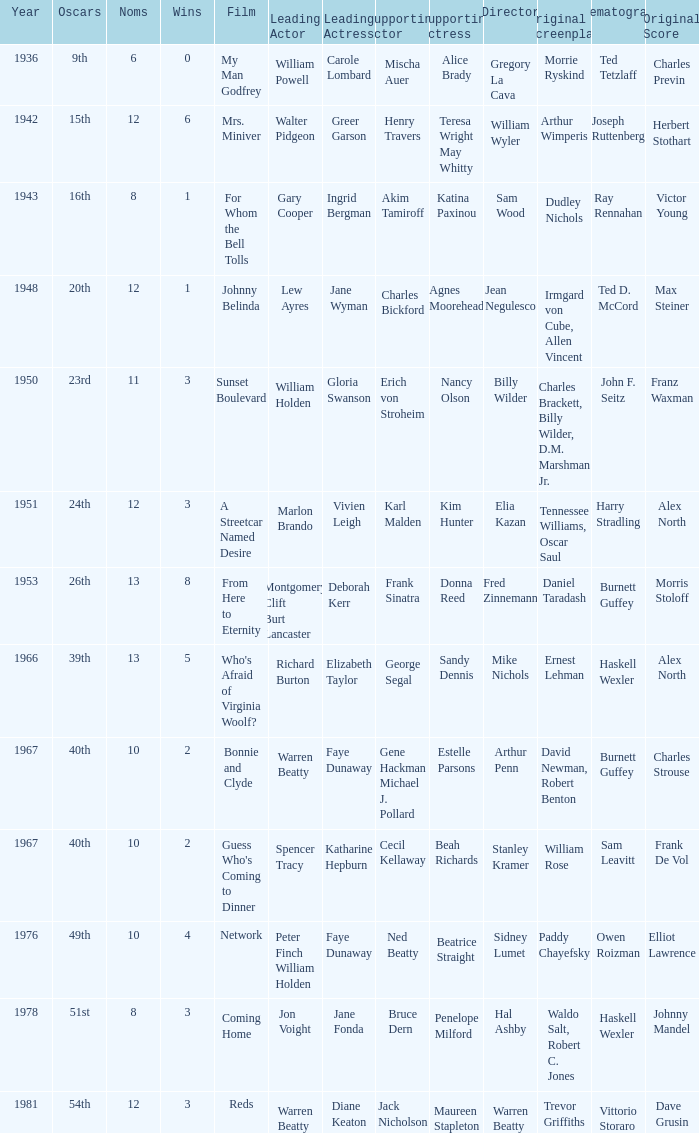Who was the leading actor in the film with a supporting actor named Cecil Kellaway? Spencer Tracy. 